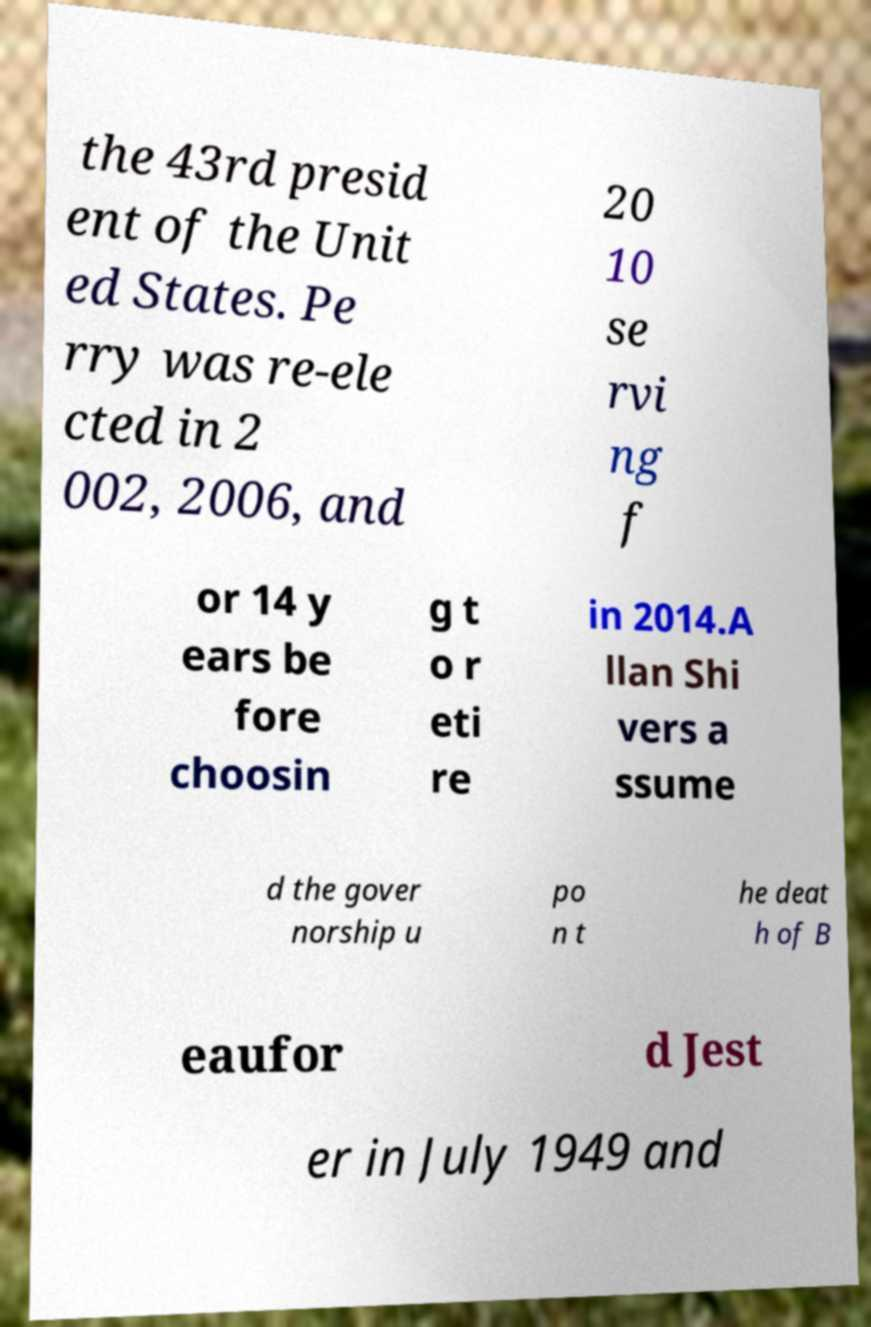Can you accurately transcribe the text from the provided image for me? the 43rd presid ent of the Unit ed States. Pe rry was re-ele cted in 2 002, 2006, and 20 10 se rvi ng f or 14 y ears be fore choosin g t o r eti re in 2014.A llan Shi vers a ssume d the gover norship u po n t he deat h of B eaufor d Jest er in July 1949 and 